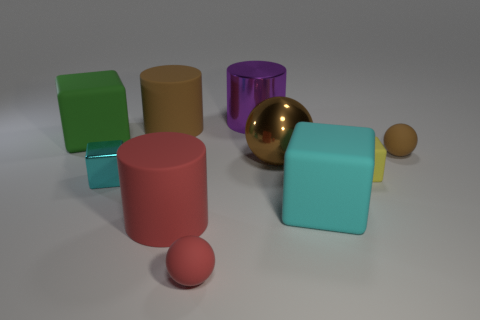What size is the other sphere that is the same color as the large metal ball?
Provide a short and direct response. Small. There is a large ball; is its color the same as the large rubber thing that is behind the green matte thing?
Make the answer very short. Yes. How many things are either cylinders to the left of the brown metallic object or large green things?
Your answer should be compact. 4. Is the number of big cubes that are to the left of the large purple metal thing the same as the number of yellow cubes on the left side of the small brown ball?
Your response must be concise. Yes. The tiny red object in front of the big brown thing that is in front of the rubber cube that is to the left of the shiny ball is made of what material?
Your response must be concise. Rubber. There is a matte thing that is both on the right side of the large red rubber cylinder and behind the brown shiny sphere; how big is it?
Your response must be concise. Small. Is the shape of the big brown matte thing the same as the tiny brown rubber object?
Your response must be concise. No. The brown object that is the same material as the tiny cyan block is what shape?
Give a very brief answer. Sphere. What number of big objects are matte cylinders or rubber things?
Ensure brevity in your answer.  4. There is a big metallic object that is behind the green rubber block; are there any purple metallic cylinders to the right of it?
Your response must be concise. No. 